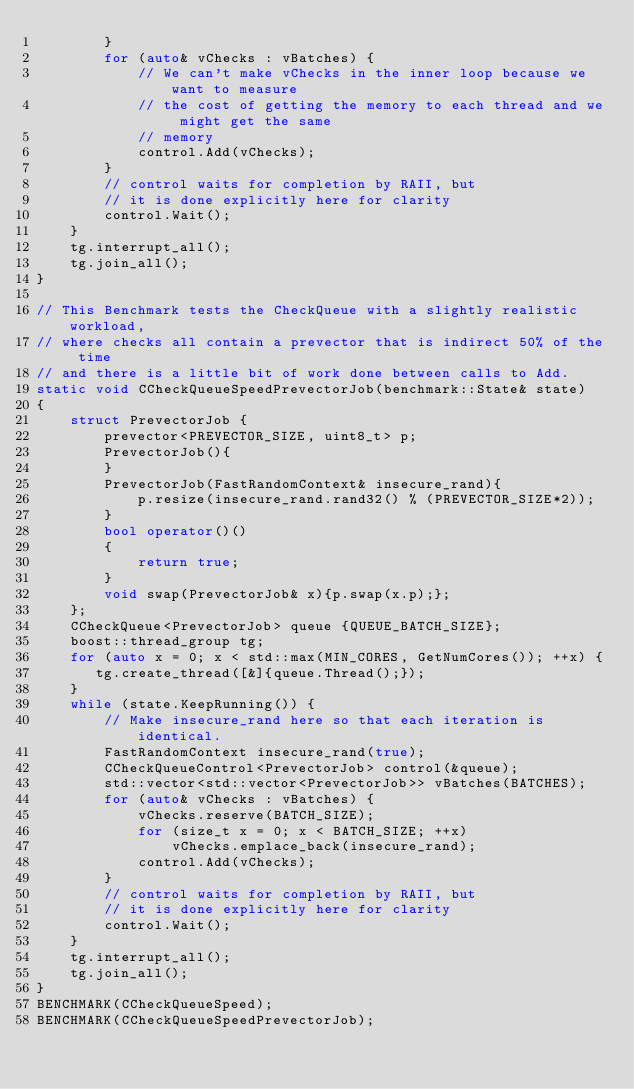<code> <loc_0><loc_0><loc_500><loc_500><_C++_>        }
        for (auto& vChecks : vBatches) {
            // We can't make vChecks in the inner loop because we want to measure
            // the cost of getting the memory to each thread and we might get the same
            // memory
            control.Add(vChecks);
        }
        // control waits for completion by RAII, but
        // it is done explicitly here for clarity
        control.Wait();
    }
    tg.interrupt_all();
    tg.join_all();
}

// This Benchmark tests the CheckQueue with a slightly realistic workload,
// where checks all contain a prevector that is indirect 50% of the time
// and there is a little bit of work done between calls to Add.
static void CCheckQueueSpeedPrevectorJob(benchmark::State& state)
{
    struct PrevectorJob {
        prevector<PREVECTOR_SIZE, uint8_t> p;
        PrevectorJob(){
        }
        PrevectorJob(FastRandomContext& insecure_rand){
            p.resize(insecure_rand.rand32() % (PREVECTOR_SIZE*2));
        }
        bool operator()()
        {
            return true;
        }
        void swap(PrevectorJob& x){p.swap(x.p);};
    };
    CCheckQueue<PrevectorJob> queue {QUEUE_BATCH_SIZE};
    boost::thread_group tg;
    for (auto x = 0; x < std::max(MIN_CORES, GetNumCores()); ++x) {
       tg.create_thread([&]{queue.Thread();});
    }
    while (state.KeepRunning()) {
        // Make insecure_rand here so that each iteration is identical.
        FastRandomContext insecure_rand(true);
        CCheckQueueControl<PrevectorJob> control(&queue);
        std::vector<std::vector<PrevectorJob>> vBatches(BATCHES);
        for (auto& vChecks : vBatches) {
            vChecks.reserve(BATCH_SIZE);
            for (size_t x = 0; x < BATCH_SIZE; ++x)
                vChecks.emplace_back(insecure_rand);
            control.Add(vChecks);
        }
        // control waits for completion by RAII, but
        // it is done explicitly here for clarity
        control.Wait();
    }
    tg.interrupt_all();
    tg.join_all();
}
BENCHMARK(CCheckQueueSpeed);
BENCHMARK(CCheckQueueSpeedPrevectorJob);
</code> 